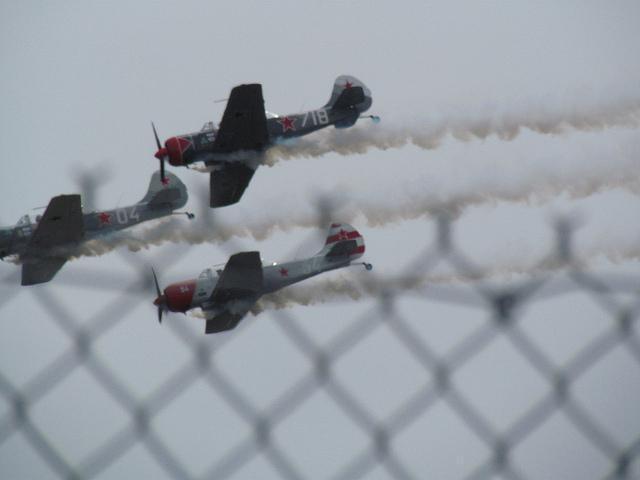How many planes are there?
Give a very brief answer. 3. How many airplanes are in the photo?
Give a very brief answer. 3. 